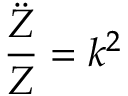<formula> <loc_0><loc_0><loc_500><loc_500>{ \frac { \ddot { Z } } { Z } } = k ^ { 2 }</formula> 